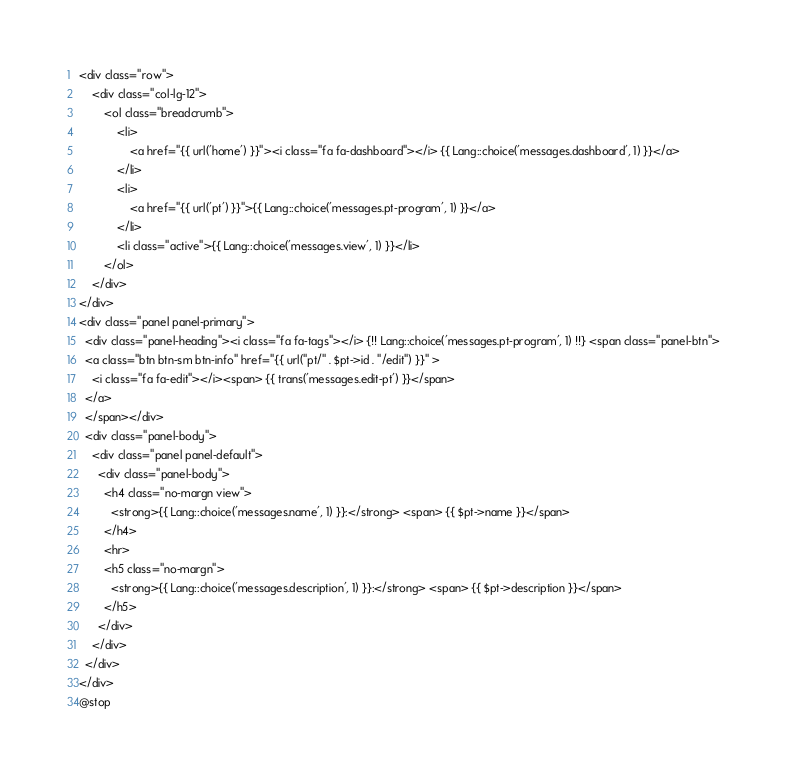<code> <loc_0><loc_0><loc_500><loc_500><_PHP_><div class="row">
    <div class="col-lg-12">
        <ol class="breadcrumb">
            <li>
                <a href="{{ url('home') }}"><i class="fa fa-dashboard"></i> {{ Lang::choice('messages.dashboard', 1) }}</a>
            </li>
            <li>
                <a href="{{ url('pt') }}">{{ Lang::choice('messages.pt-program', 1) }}</a>
            </li>
            <li class="active">{{ Lang::choice('messages.view', 1) }}</li>
        </ol>
    </div>
</div>
<div class="panel panel-primary">
  <div class="panel-heading"><i class="fa fa-tags"></i> {!! Lang::choice('messages.pt-program', 1) !!} <span class="panel-btn">
  <a class="btn btn-sm btn-info" href="{{ url("pt/" . $pt->id . "/edit") }}" >
    <i class="fa fa-edit"></i><span> {{ trans('messages.edit-pt') }}</span>
  </a>
  </span></div>
  <div class="panel-body">
    <div class="panel panel-default">
      <div class="panel-body">
        <h4 class="no-margn view">
          <strong>{{ Lang::choice('messages.name', 1) }}:</strong> <span> {{ $pt->name }}</span>
        </h4>
        <hr>
        <h5 class="no-margn">
          <strong>{{ Lang::choice('messages.description', 1) }}:</strong> <span> {{ $pt->description }}</span>
        </h5>
      </div>
    </div>
  </div>
</div>
@stop</code> 